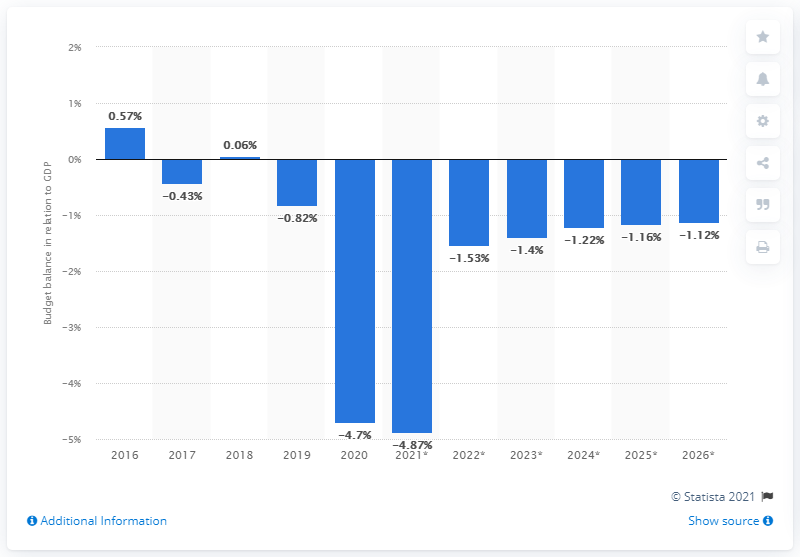Point out several critical features in this image. In 2020, Thailand's budget balance was last in relation to its Gross Domestic Product (GDP). 